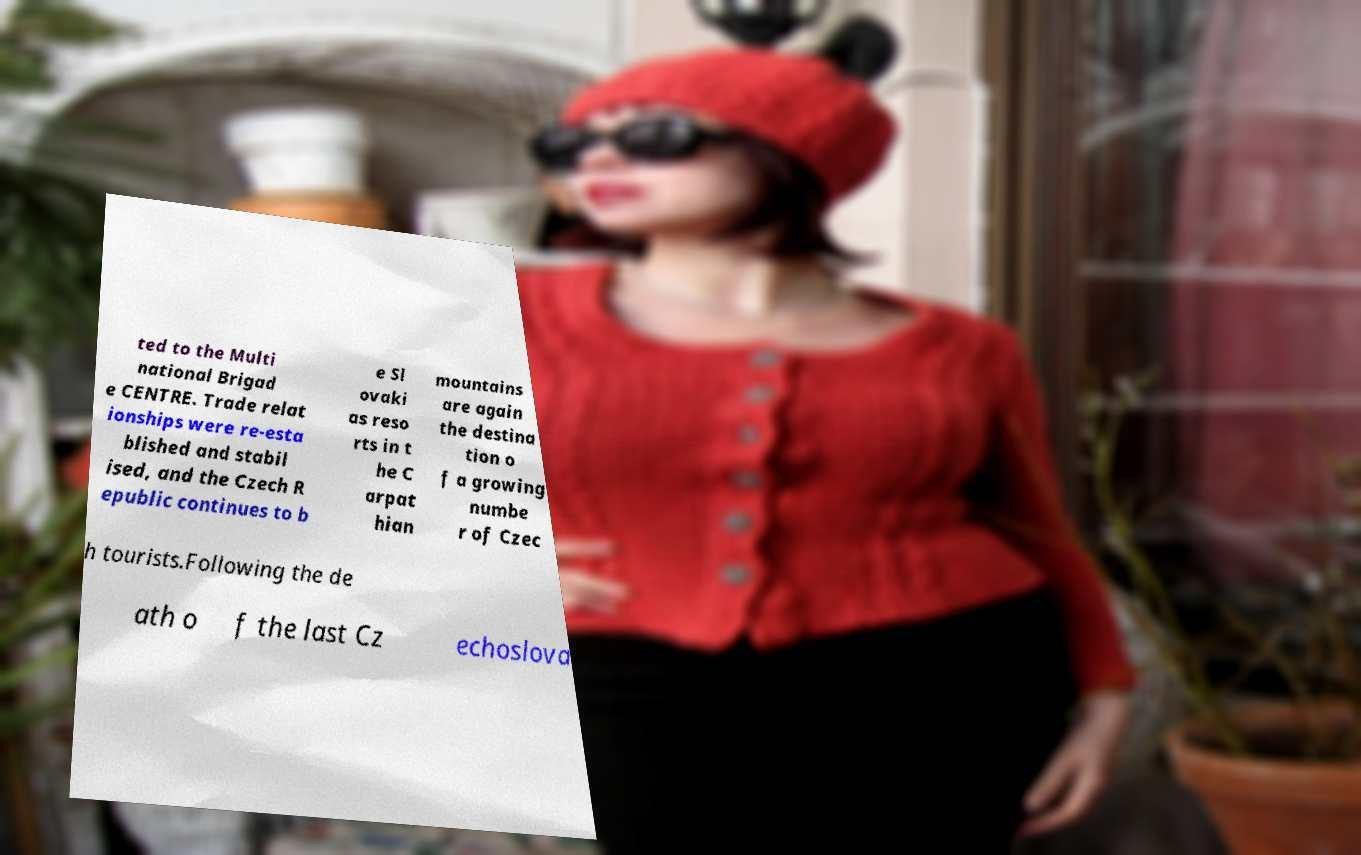Can you accurately transcribe the text from the provided image for me? ted to the Multi national Brigad e CENTRE. Trade relat ionships were re-esta blished and stabil ised, and the Czech R epublic continues to b e Sl ovaki as reso rts in t he C arpat hian mountains are again the destina tion o f a growing numbe r of Czec h tourists.Following the de ath o f the last Cz echoslova 